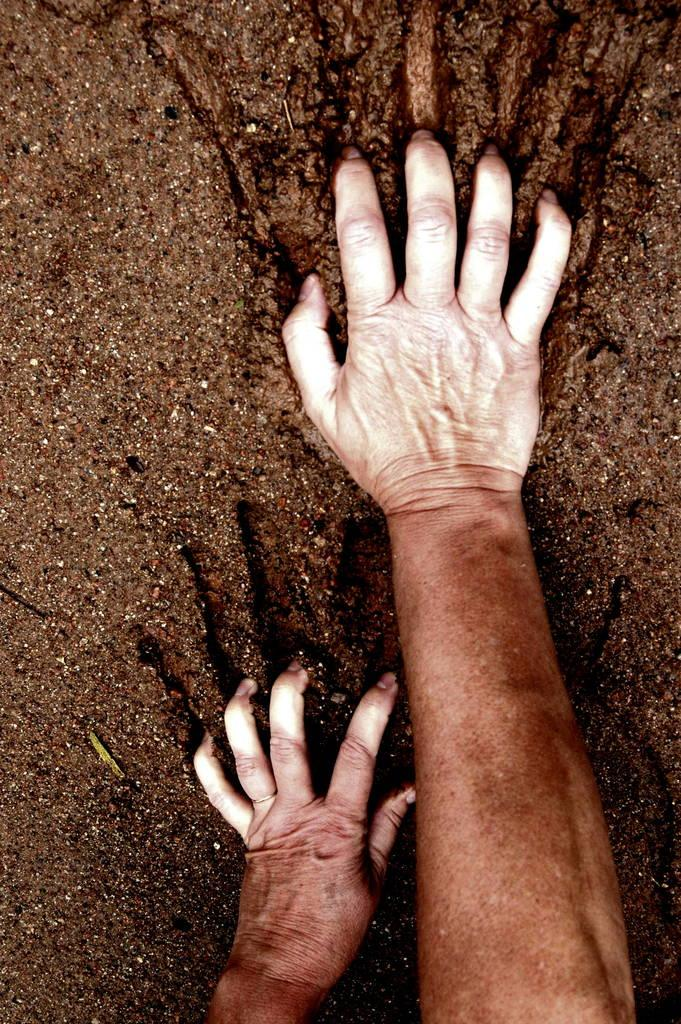What body parts are visible in the image? There are a person's hands in the image. What substance can be seen on the person's hands? There is mud in the image. What type of clam is being held by the person in the image? There is no clam present in the image; only a person's hands and mud are visible. 